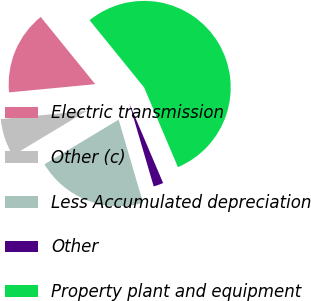Convert chart to OTSL. <chart><loc_0><loc_0><loc_500><loc_500><pie_chart><fcel>Electric transmission<fcel>Other (c)<fcel>Less Accumulated depreciation<fcel>Other<fcel>Property plant and equipment<nl><fcel>15.67%<fcel>7.1%<fcel>20.93%<fcel>1.84%<fcel>54.45%<nl></chart> 